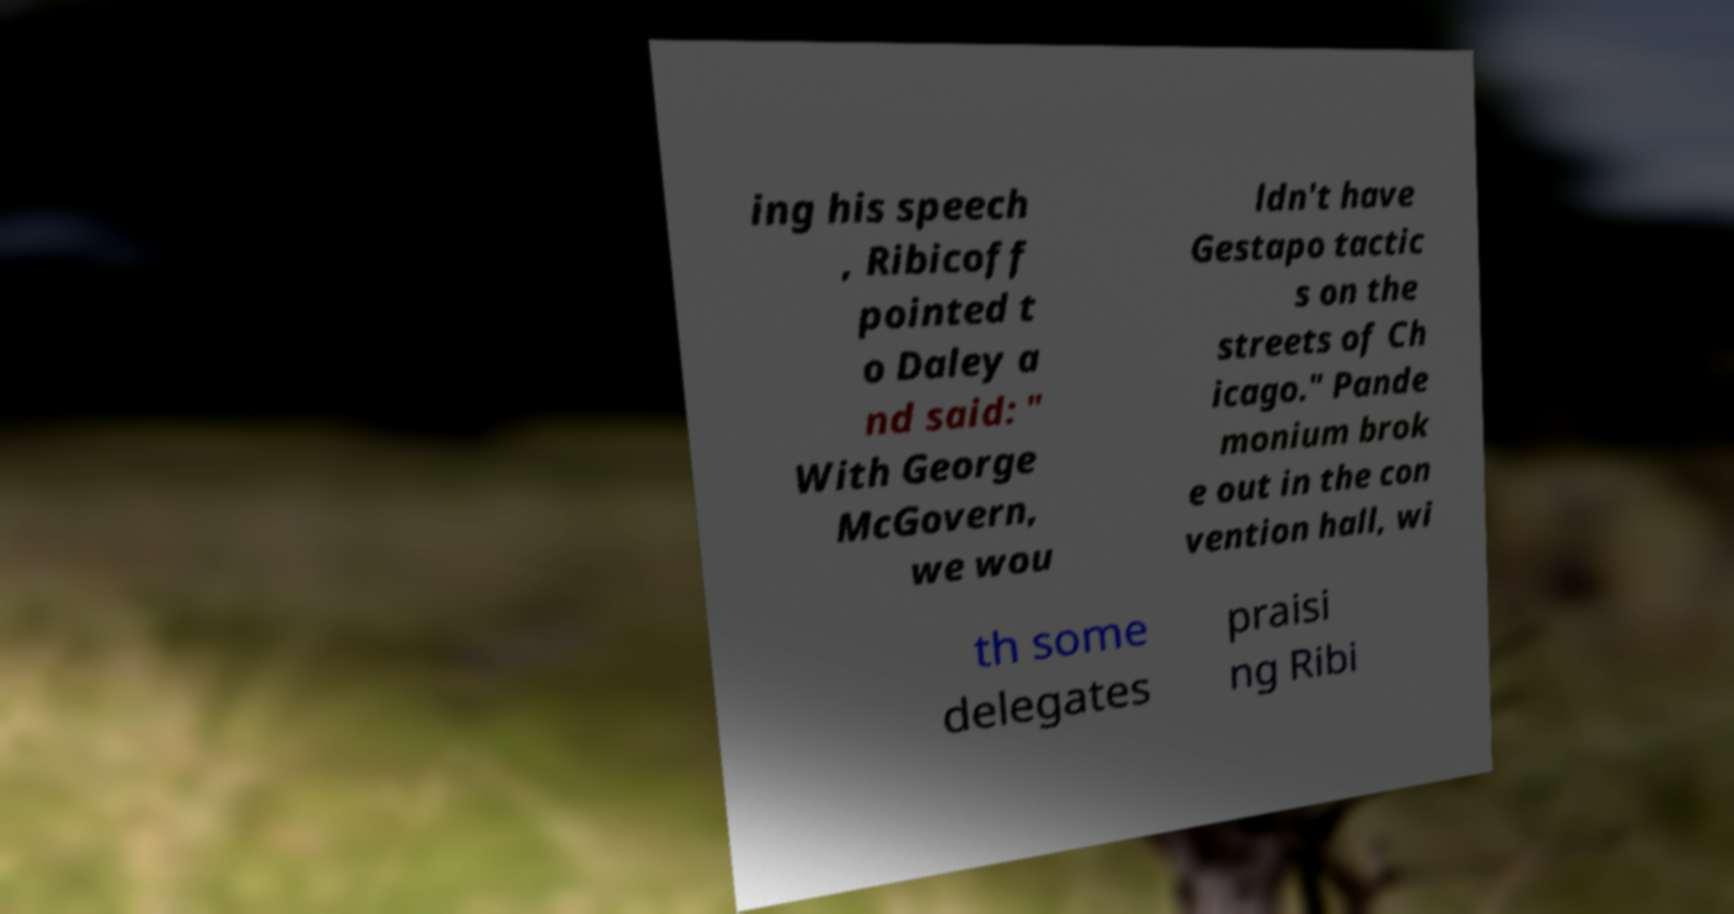What messages or text are displayed in this image? I need them in a readable, typed format. ing his speech , Ribicoff pointed t o Daley a nd said: " With George McGovern, we wou ldn't have Gestapo tactic s on the streets of Ch icago." Pande monium brok e out in the con vention hall, wi th some delegates praisi ng Ribi 